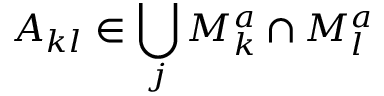<formula> <loc_0><loc_0><loc_500><loc_500>A _ { k l } \in \bigcup _ { j } M _ { k } ^ { a } \cap M _ { l } ^ { a }</formula> 